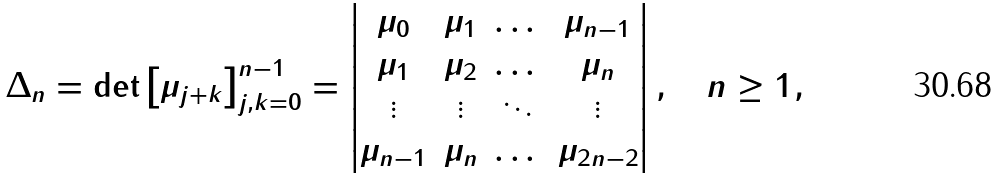<formula> <loc_0><loc_0><loc_500><loc_500>\Delta _ { n } = \det \left [ \mu _ { j + k } \right ] _ { j , k = 0 } ^ { n - 1 } = \left | \begin{matrix} \mu _ { 0 } & \mu _ { 1 } & \dots & \mu _ { n - 1 } \\ \mu _ { 1 } & \mu _ { 2 } & \dots & \mu _ { n } \\ \vdots & \vdots & \ddots & \vdots \\ \mu _ { n - 1 } & \mu _ { n } & \dots & \mu _ { 2 n - 2 } \end{matrix} \right | , \quad n \geq 1 ,</formula> 